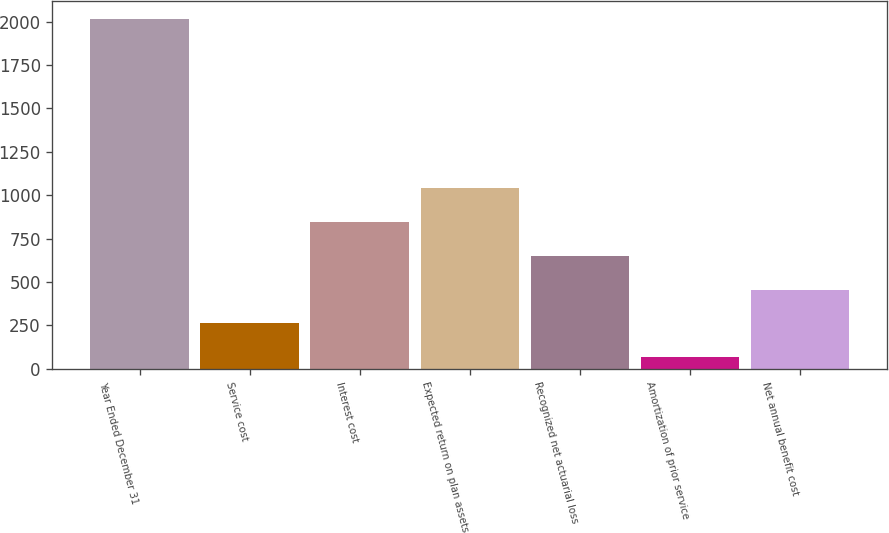Convert chart to OTSL. <chart><loc_0><loc_0><loc_500><loc_500><bar_chart><fcel>Year Ended December 31<fcel>Service cost<fcel>Interest cost<fcel>Expected return on plan assets<fcel>Recognized net actuarial loss<fcel>Amortization of prior service<fcel>Net annual benefit cost<nl><fcel>2015<fcel>261.8<fcel>846.2<fcel>1041<fcel>651.4<fcel>67<fcel>456.6<nl></chart> 